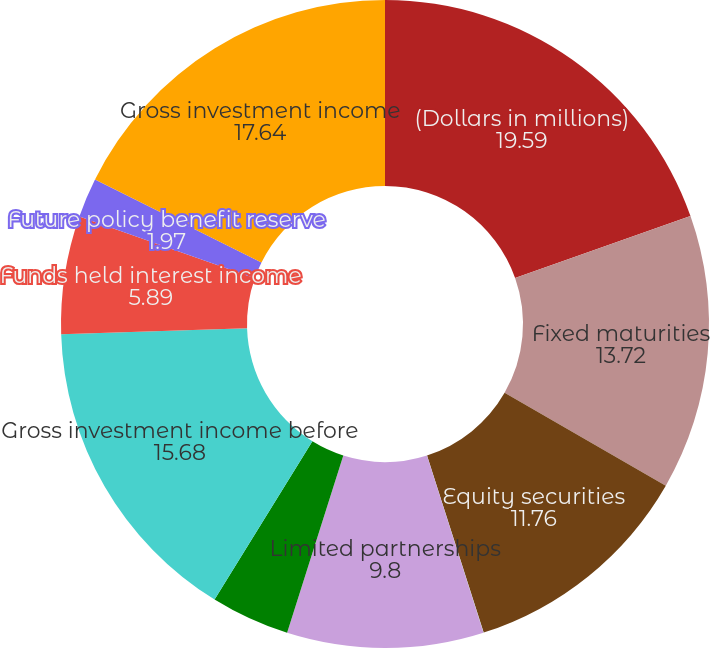Convert chart. <chart><loc_0><loc_0><loc_500><loc_500><pie_chart><fcel>(Dollars in millions)<fcel>Fixed maturities<fcel>Equity securities<fcel>Short-term investments and<fcel>Limited partnerships<fcel>Other<fcel>Gross investment income before<fcel>Funds held interest income<fcel>Future policy benefit reserve<fcel>Gross investment income<nl><fcel>19.59%<fcel>13.72%<fcel>11.76%<fcel>0.01%<fcel>9.8%<fcel>3.93%<fcel>15.68%<fcel>5.89%<fcel>1.97%<fcel>17.64%<nl></chart> 